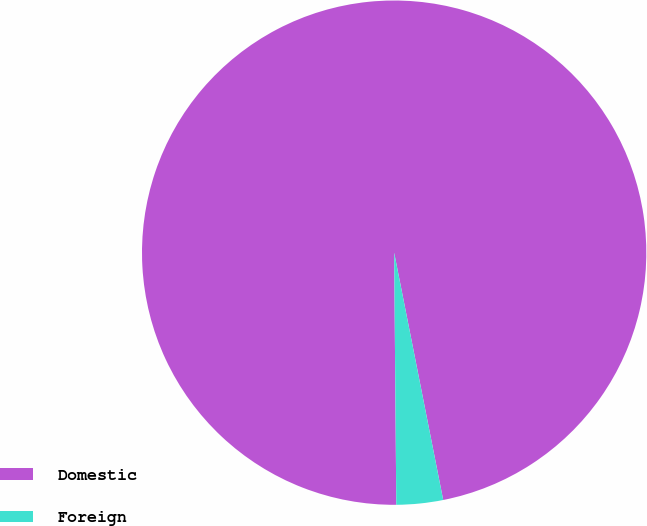<chart> <loc_0><loc_0><loc_500><loc_500><pie_chart><fcel>Domestic<fcel>Foreign<nl><fcel>97.02%<fcel>2.98%<nl></chart> 